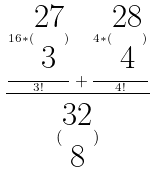<formula> <loc_0><loc_0><loc_500><loc_500>\frac { \frac { 1 6 * ( \begin{matrix} 2 7 \\ 3 \end{matrix} ) } { 3 ! } + \frac { 4 * ( \begin{matrix} 2 8 \\ 4 \end{matrix} ) } { 4 ! } } { ( \begin{matrix} 3 2 \\ 8 \end{matrix} ) }</formula> 